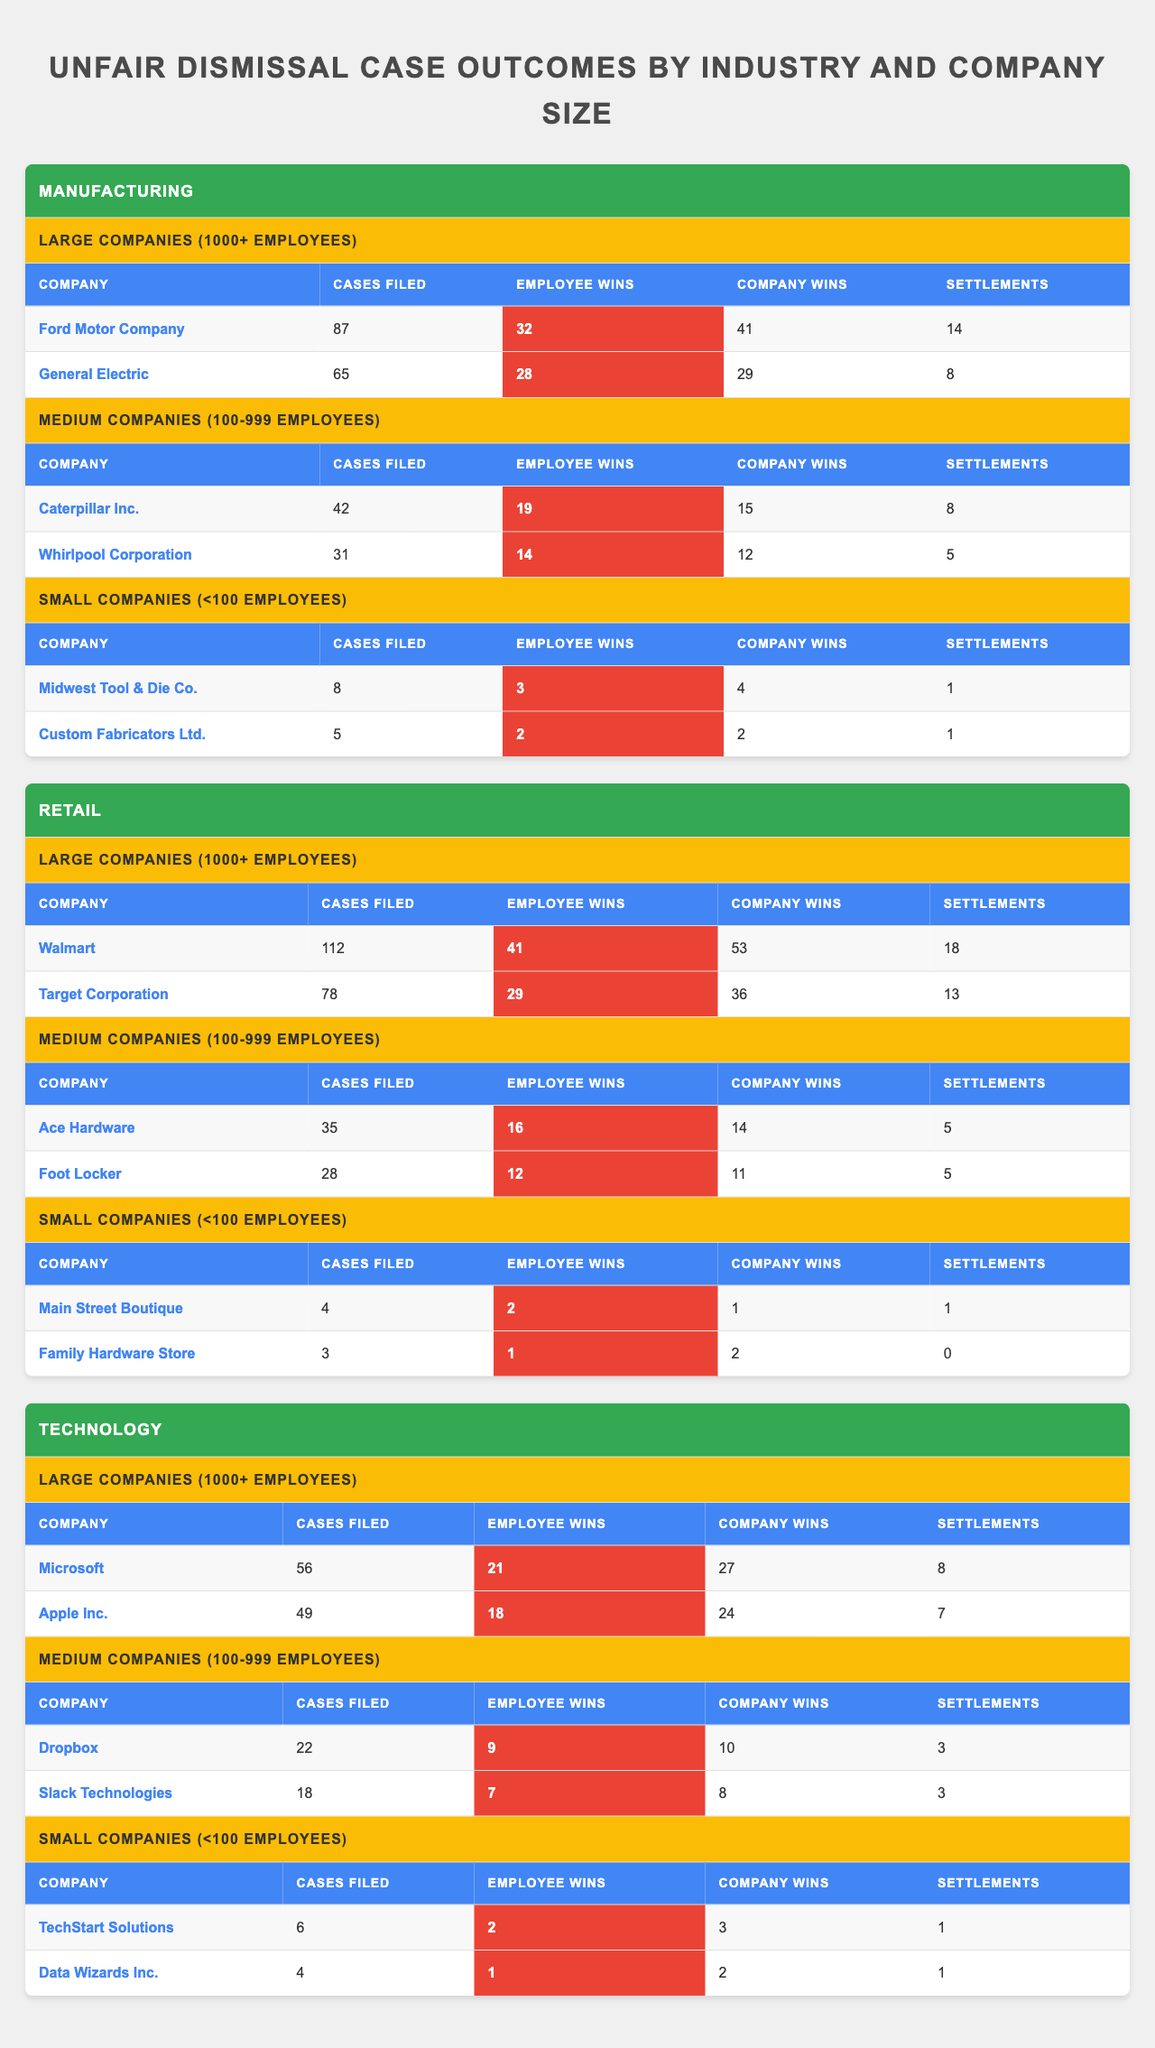What is the total number of cases filed in the Manufacturing industry? To find the total cases filed in the Manufacturing industry, I need to sum up the cases filed by each company: 87 (Ford) + 65 (General Electric) + 42 (Caterpillar) + 31 (Whirlpool) + 8 (Midwest Tool) + 5 (Custom Fabricators) = 238.
Answer: 238 Which retail company had the most employee wins? Looking at the Retail section, I compare the Employee Wins for each company: Walmart has 41 wins, Target has 29, Ace Hardware has 16, Foot Locker has 12, Main Street Boutique has 2, and Family Hardware Store has 1. Walmart has the highest with 41 wins.
Answer: Walmart How many employee wins did the large technology companies have combined? To find the combined employee wins of large technology companies, I sum their wins: 21 (Microsoft) + 18 (Apple) = 39.
Answer: 39 Did any small retail company achieve more settlements than cases filed? In the small retail category, Main Street Boutique filed 4 cases and had 1 settlement. Family Hardware Store filed 3 cases with no settlements. Since both have settlements less than cases filed, the answer is no.
Answer: No What percentage of cases filed in Manufacturing resulted in employee wins? First, I calculate the total cases filed (238) and total employee wins (32 + 28 + 19 + 14 + 3 + 2 = 98). The percentage is then (98 / 238) * 100 ≈ 41.2%.
Answer: 41.2% Which industry has the highest total number of company wins? For this, I sum the company wins for each industry: Manufacturing (41 + 29 + 15 + 12 + 4 + 2 = 103), Retail (53 + 36 + 14 + 11 + 1 + 2 = 117), Technology (27 + 24 + 10 + 8 + 3 + 2 = 74). Retail has the highest sum of 117.
Answer: Retail In which industry did the smallest company have the highest employee wins? Checking the small companies in all industries, Midwest Tool & Die Co. had 3 employee wins in Manufacturing, Main Street Boutique had 2 in Retail, and TechStart Solutions had 2 in Technology. The highest is 3 wins in Manufacturing.
Answer: Manufacturing What is the average number of settlements among large companies in the Technology industry? The large technology companies are Microsoft and Apple, with settlements of 8 and 7, respectively. The average is (8 + 7) / 2 = 7.5.
Answer: 7.5 How many cases were filed by the company with the highest number of employee wins among the large companies? The company with the highest employee wins among large companies is Walmart with 41 wins, which filed 112 cases.
Answer: 112 Is it true that more than half of the cases filed in the medium-sized companies resulted in employee wins? In medium-sized companies, the cases filed are: Caterpillar (42), Whirlpool (31), Ace Hardware (35), and Foot Locker (28) totaling 136 cases filed. The employee wins are: 19 + 14 + 16 + 12 = 61. Since 61 is not more than half of 136, the answer is no.
Answer: No 